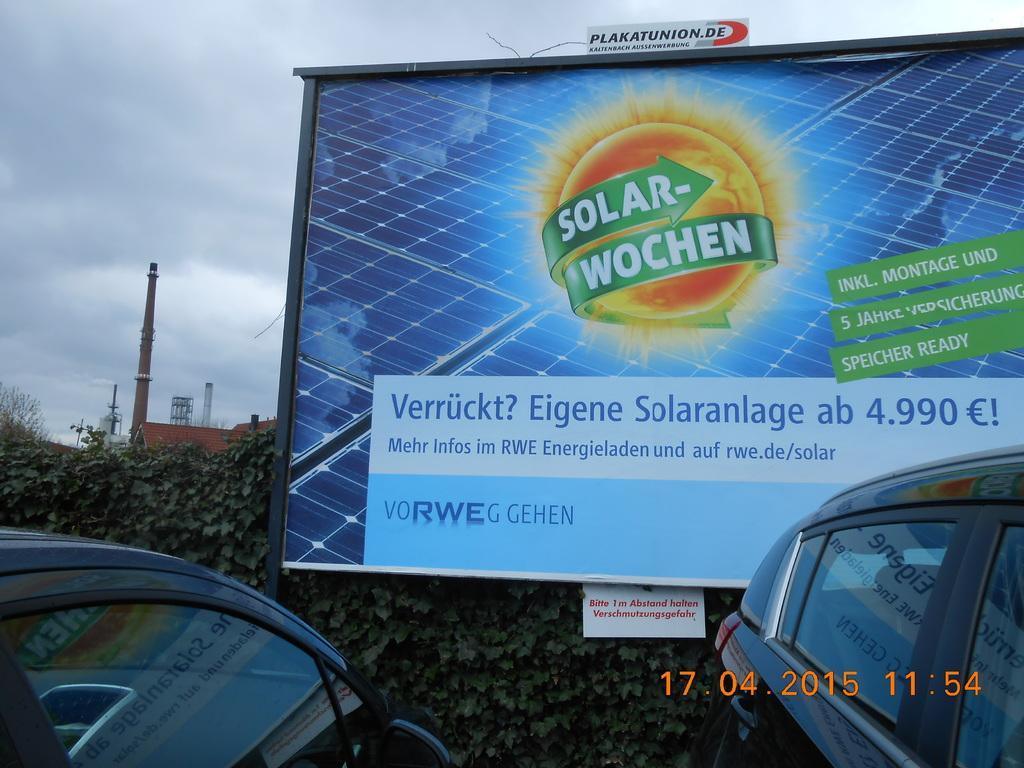Please provide a concise description of this image. In this picture we can see a hoarding, cars, trees, building, poles and in the background we can see the sky with clouds. 